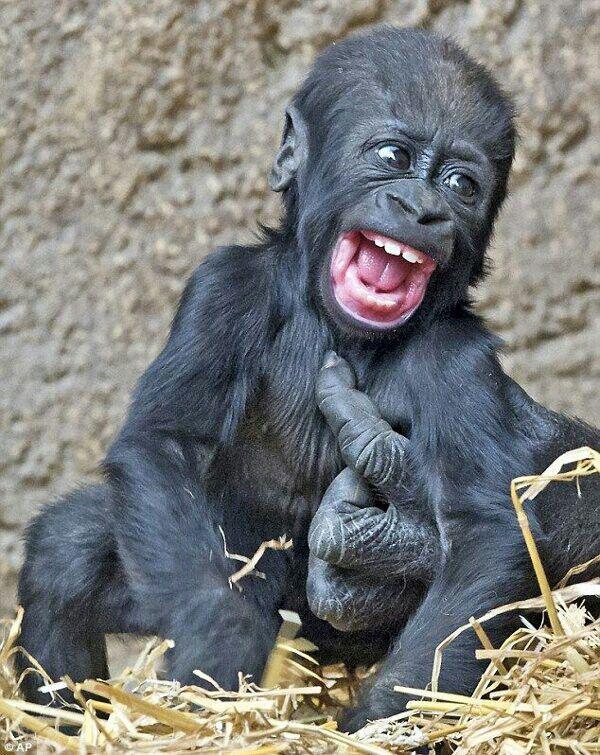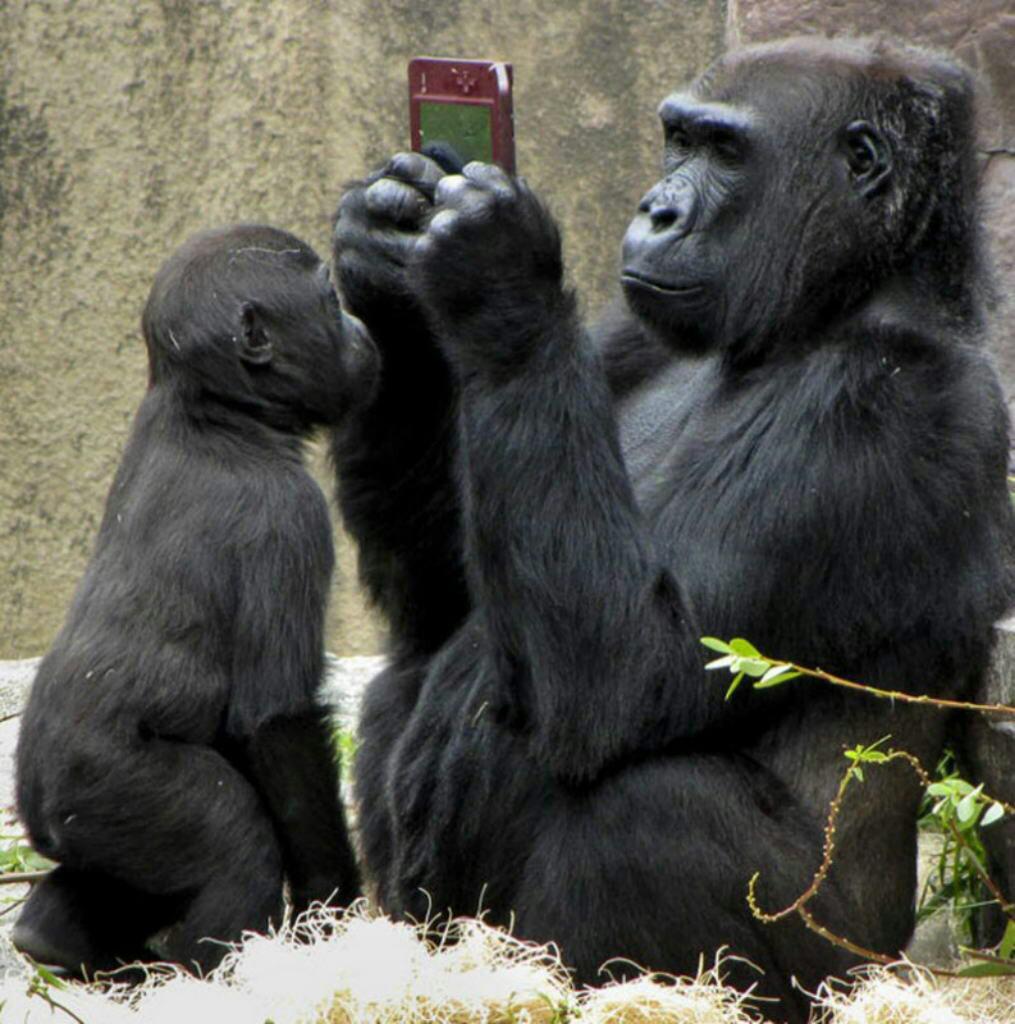The first image is the image on the left, the second image is the image on the right. Given the left and right images, does the statement "An animal is looking at the camera and flashing its middle finger in the left image." hold true? Answer yes or no. No. The first image is the image on the left, the second image is the image on the right. For the images shown, is this caption "The left image shows a large forward-facing ape with its elbows bent and the hand on the right side flipping up its middle finger." true? Answer yes or no. No. 